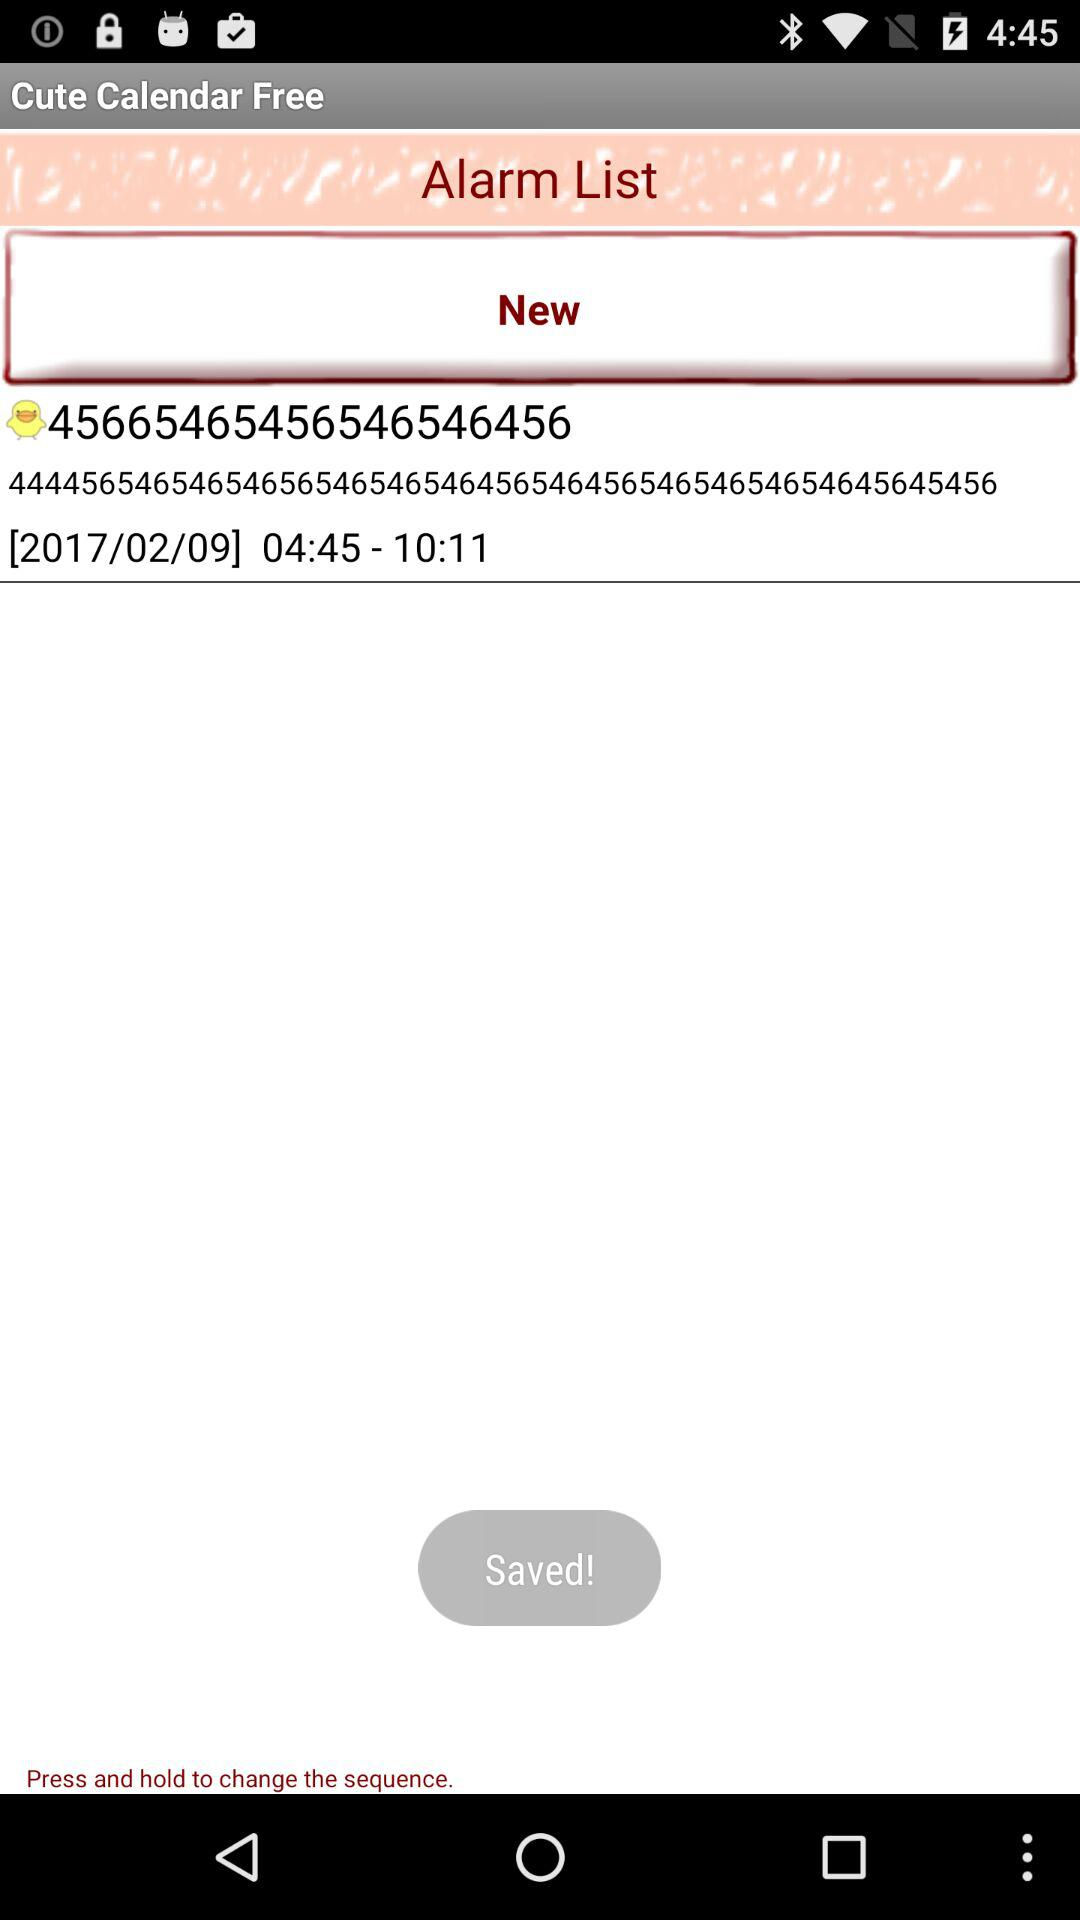What is the alarm time and date? The alarm time is 04:45–10:11 on 2017/02/09. 